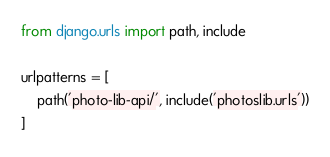Convert code to text. <code><loc_0><loc_0><loc_500><loc_500><_Python_>from django.urls import path, include

urlpatterns = [
    path('photo-lib-api/', include('photoslib.urls'))
]
</code> 